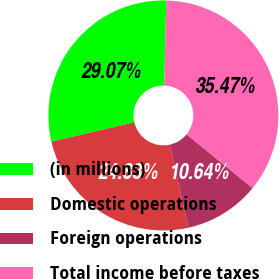Convert chart. <chart><loc_0><loc_0><loc_500><loc_500><pie_chart><fcel>(in millions)<fcel>Domestic operations<fcel>Foreign operations<fcel>Total income before taxes<nl><fcel>29.07%<fcel>24.83%<fcel>10.64%<fcel>35.47%<nl></chart> 